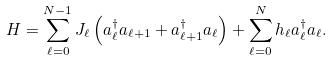Convert formula to latex. <formula><loc_0><loc_0><loc_500><loc_500>H = \sum _ { \ell = 0 } ^ { N - 1 } J _ { \ell } \left ( a ^ { \dagger } _ { \ell } a _ { \ell + 1 } + a ^ { \dagger } _ { \ell + 1 } a _ { \ell } \right ) + \sum _ { \ell = 0 } ^ { N } h _ { \ell } a ^ { \dagger } _ { \ell } a _ { \ell } .</formula> 